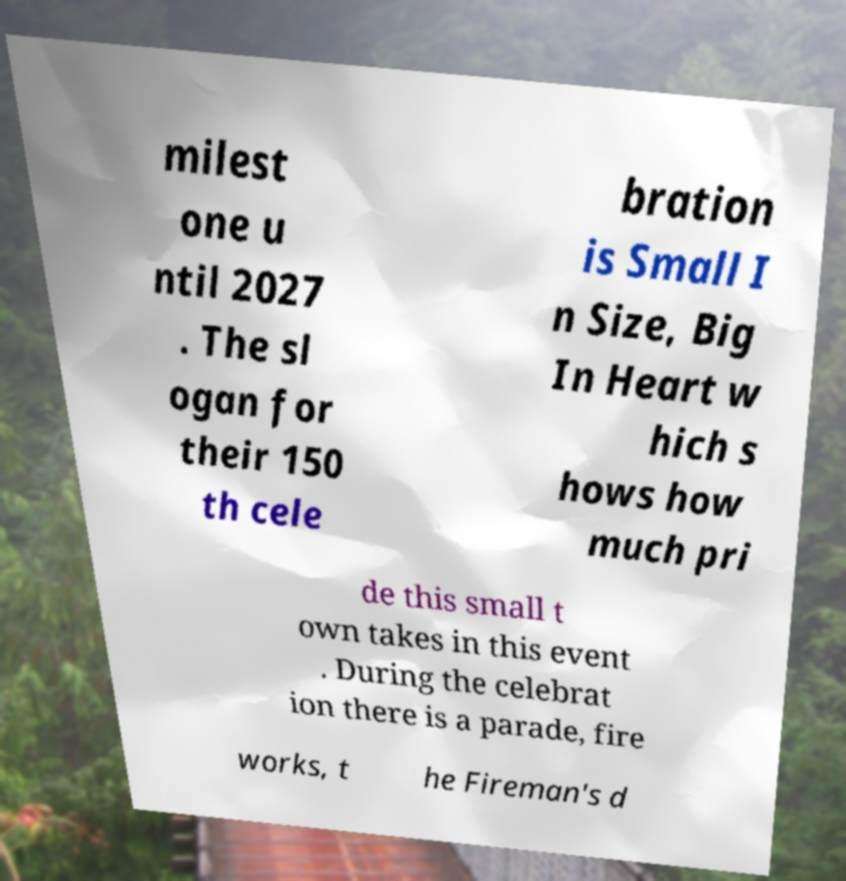Can you read and provide the text displayed in the image?This photo seems to have some interesting text. Can you extract and type it out for me? milest one u ntil 2027 . The sl ogan for their 150 th cele bration is Small I n Size, Big In Heart w hich s hows how much pri de this small t own takes in this event . During the celebrat ion there is a parade, fire works, t he Fireman's d 